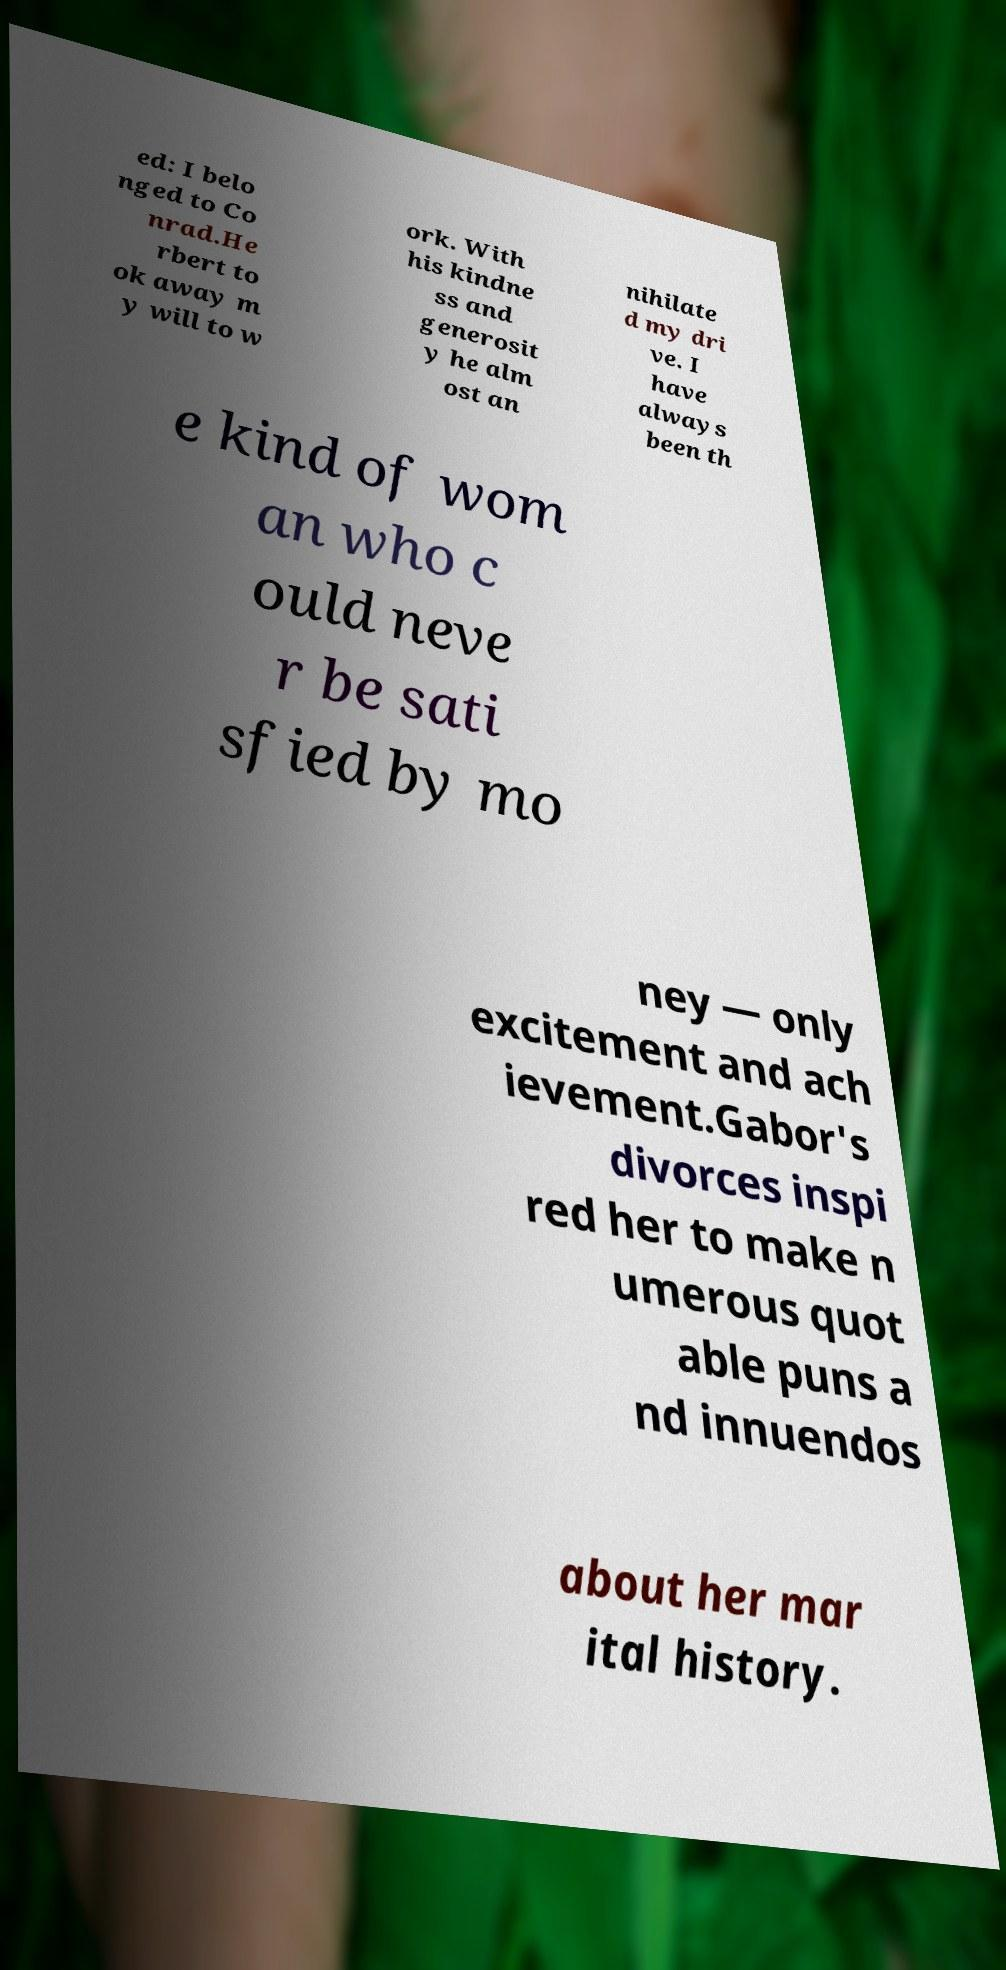Can you accurately transcribe the text from the provided image for me? ed: I belo nged to Co nrad.He rbert to ok away m y will to w ork. With his kindne ss and generosit y he alm ost an nihilate d my dri ve. I have always been th e kind of wom an who c ould neve r be sati sfied by mo ney — only excitement and ach ievement.Gabor's divorces inspi red her to make n umerous quot able puns a nd innuendos about her mar ital history. 